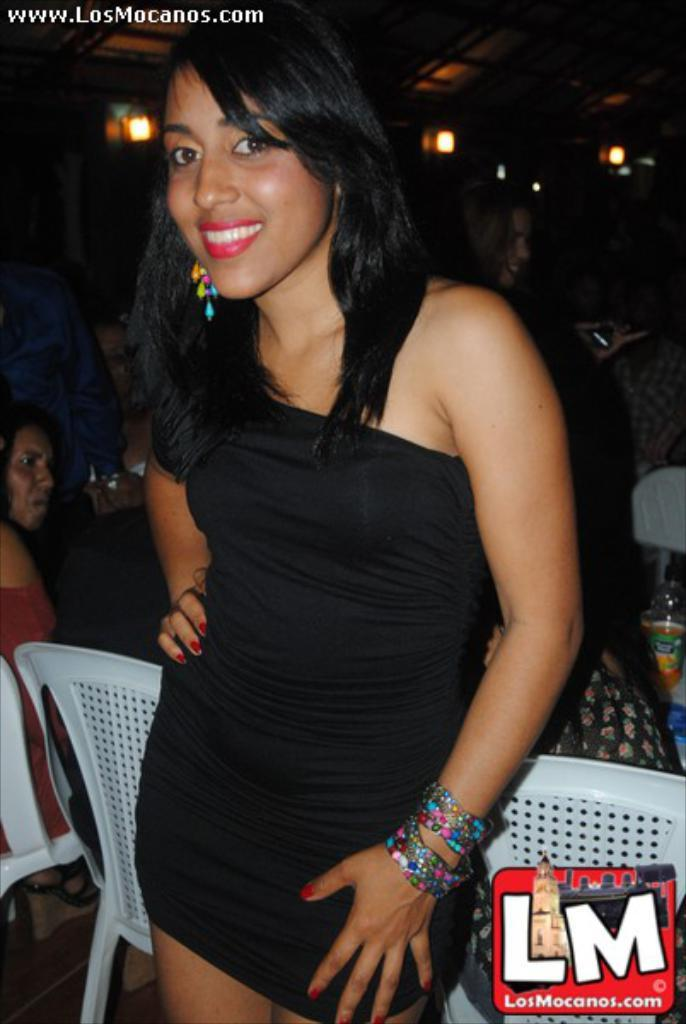Who is the main subject in the image? There is a woman in the image. Can you describe the woman's appearance? The woman is beautiful. What is the woman doing in the image? The woman is standing and smiling. What is the woman wearing in the image? The woman is wearing a black top. What can be seen in the background of the image? There are white chairs in the background. What is visible at the top of the image? There are lights at the top of the image. How does the woman run on the railway in the image? There is no railway present in the image, and the woman is not running. 